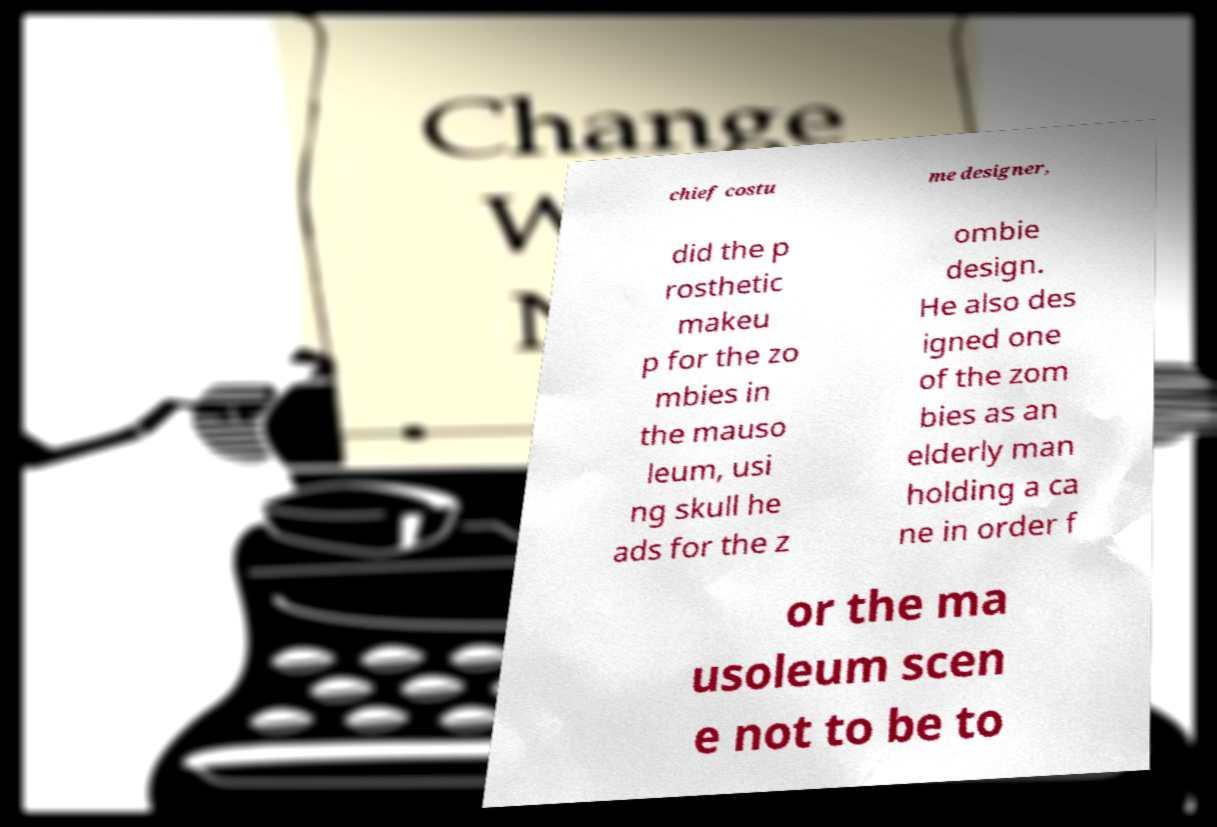Please read and relay the text visible in this image. What does it say? chief costu me designer, did the p rosthetic makeu p for the zo mbies in the mauso leum, usi ng skull he ads for the z ombie design. He also des igned one of the zom bies as an elderly man holding a ca ne in order f or the ma usoleum scen e not to be to 